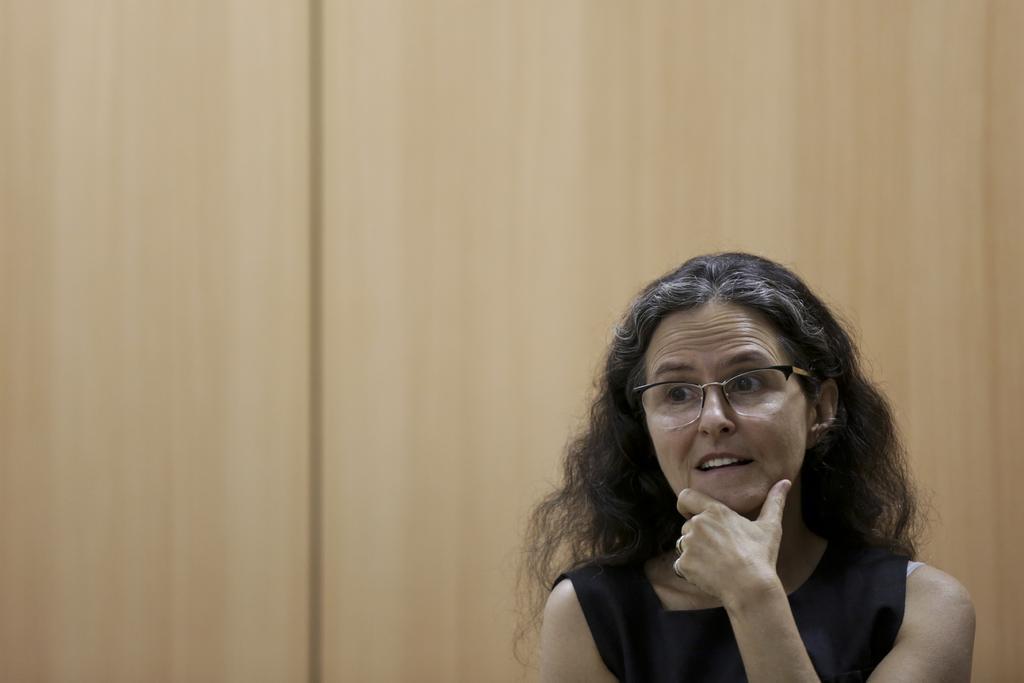Who is present in the image? There is a woman in the image. What accessory is the woman wearing? The woman is wearing spectacles. What type of material can be seen in the background of the image? There is a wooden wall in the background of the image. What type of stamp can be seen on the woman's forehead in the image? There is no stamp present on the woman's forehead in the image. 